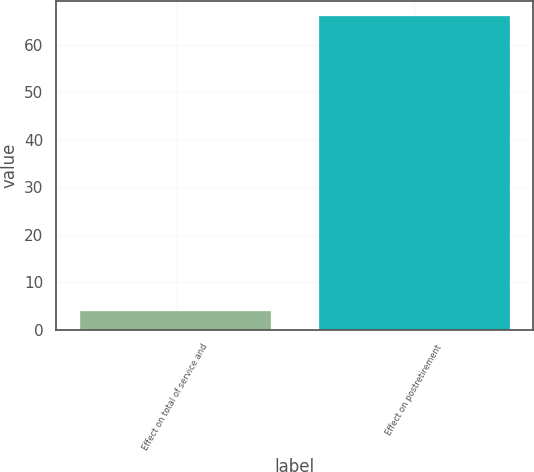<chart> <loc_0><loc_0><loc_500><loc_500><bar_chart><fcel>Effect on total of service and<fcel>Effect on postretirement<nl><fcel>4<fcel>66<nl></chart> 